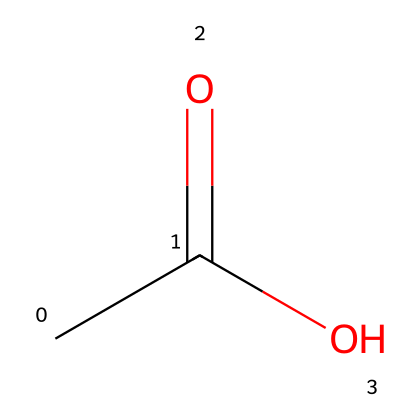What is the name of this chemical? The SMILES representation "CC(=O)O" describes acetic acid, which is a well-known simple carboxylic acid.
Answer: acetic acid How many carbon atoms are in this chemical? In the SMILES "CC(=O)O," there are two 'C' symbols indicating two carbon atoms.
Answer: 2 What is the functional group present in this chemical? The presence of "C(=O)O" indicates a carboxylic acid functional group (-COOH), which is characteristic of acids.
Answer: carboxylic acid What type of acid is this chemical classified as? Acetic acid is classified as a weak acid because it partially dissociates in solution.
Answer: weak acid What is the pH level of a typical solution of this chemical? A typical aqueous solution of acetic acid has a pH level of around 2 to 3, indicating its acidic nature.
Answer: 2 to 3 In what area of film development is this chemical commonly used? Acetic acid is commonly used in film preservation as a stabilizer and to neutralize alkaline conditions that can degrade film materials.
Answer: film preservation How does this chemical affect film deterioration? Acetic acid helps to reduce the risk of film deterioration by mitigating the presence of harmful alkaline residues in the film material.
Answer: mitigate deterioration 